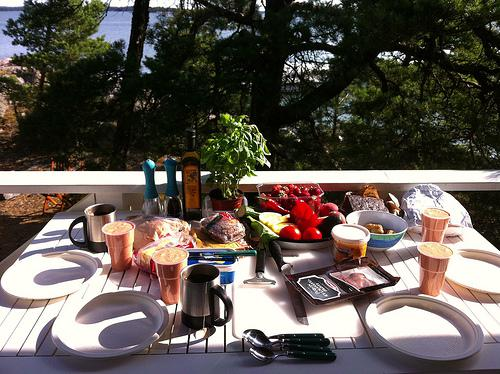Question: how many cups are present?
Choices:
A. Eight.
B. Nine.
C. Four.
D. Ten.
Answer with the letter. Answer: C Question: where is this taking place?
Choices:
A. Beach.
B. At a waterfront home.
C. Pier.
D. Near sand.
Answer with the letter. Answer: B Question: how many plates are there?
Choices:
A. Five.
B. Six.
C. Four.
D. Seven.
Answer with the letter. Answer: C Question: what kind of fruit is on the table?
Choices:
A. Apples.
B. Oranges.
C. Strawberries.
D. Bananas.
Answer with the letter. Answer: C 